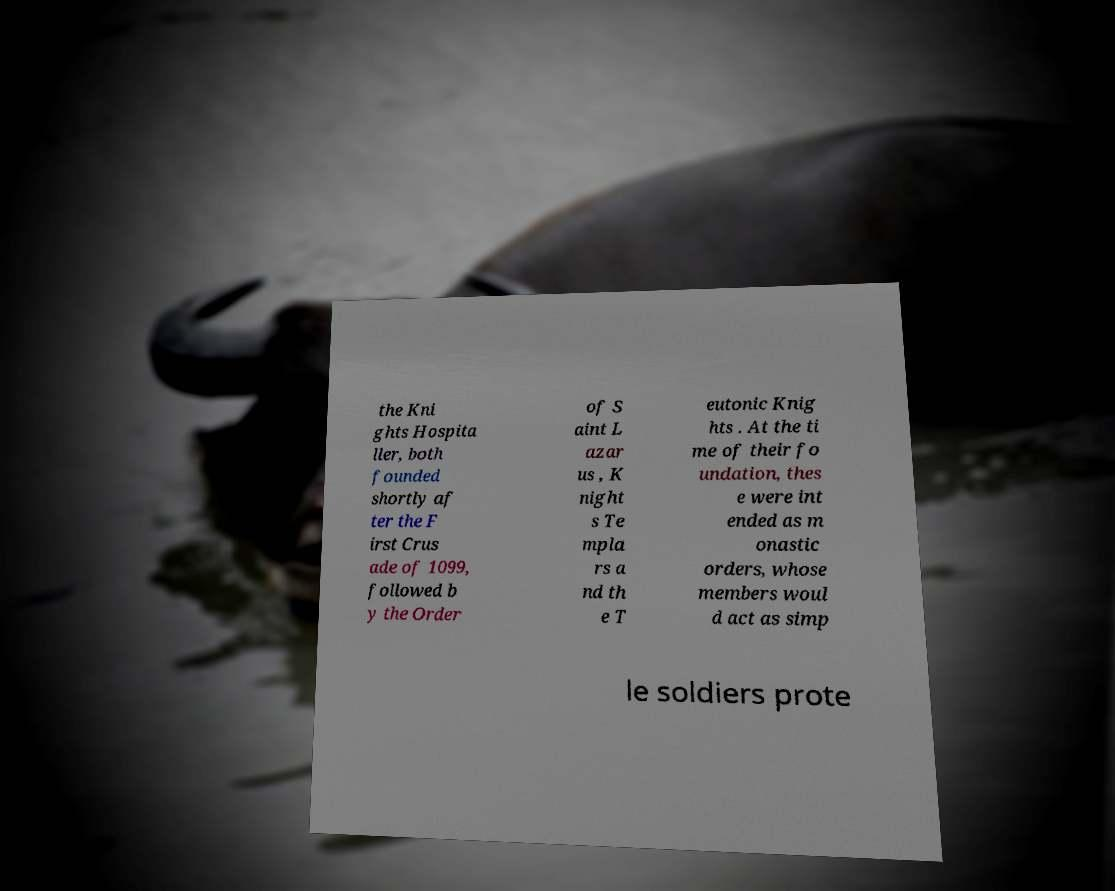Can you accurately transcribe the text from the provided image for me? the Kni ghts Hospita ller, both founded shortly af ter the F irst Crus ade of 1099, followed b y the Order of S aint L azar us , K night s Te mpla rs a nd th e T eutonic Knig hts . At the ti me of their fo undation, thes e were int ended as m onastic orders, whose members woul d act as simp le soldiers prote 